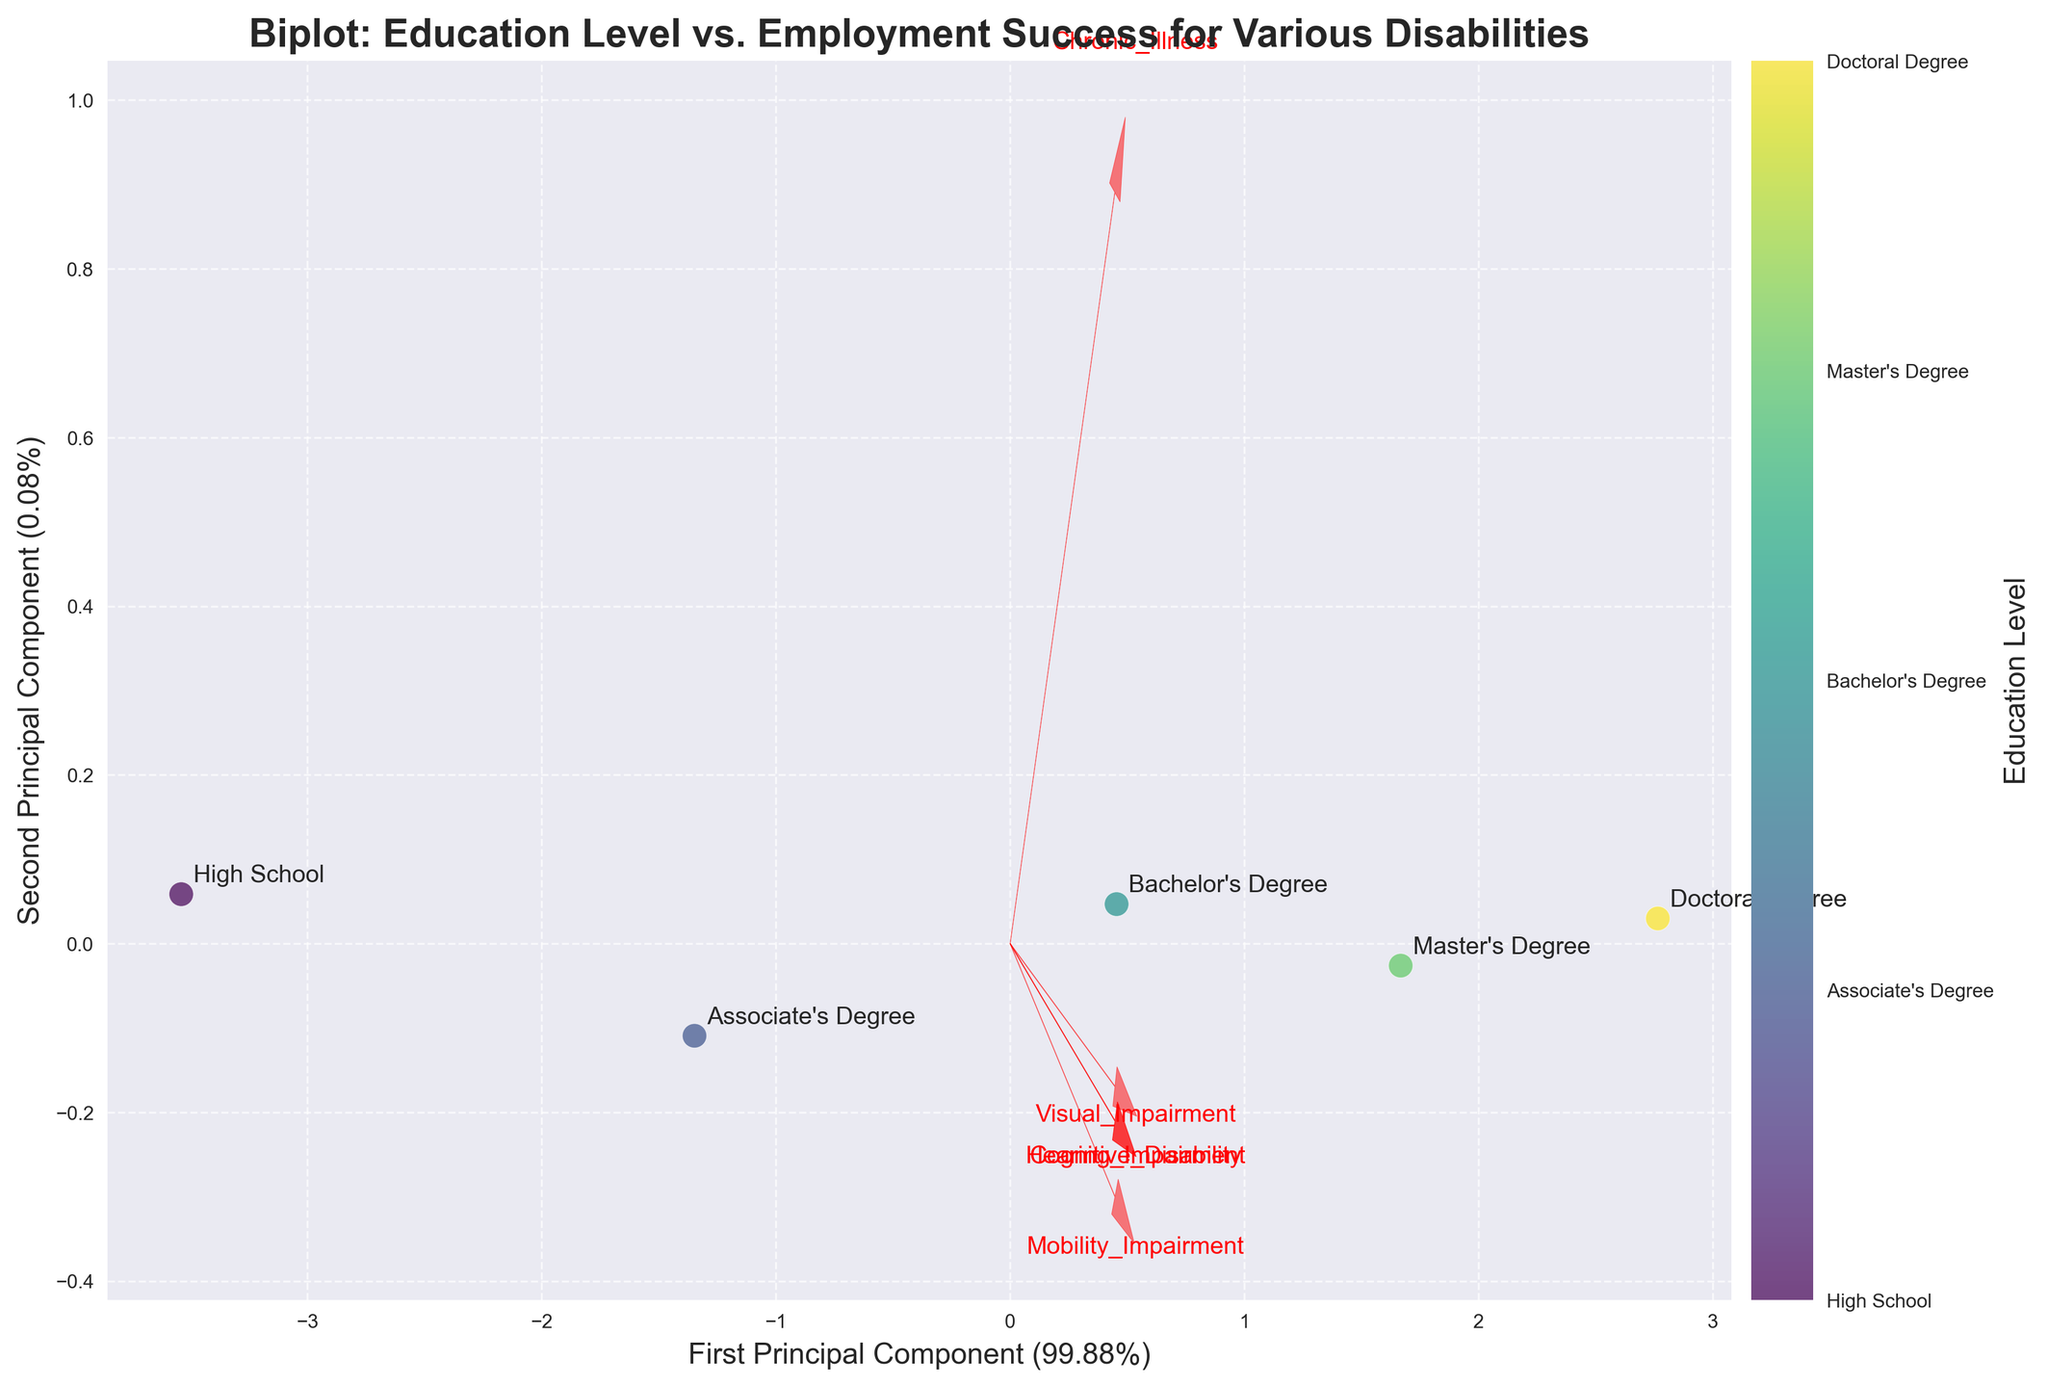How many data points are plotted in the figure? The scatter plot displays labeled points for each level of education. By counting the labels, we see there are data points for High School, Associate's Degree, Bachelor's Degree, Master's Degree, and Doctoral Degree.
Answer: Five What are the axes labeled in the biplot? The horizontal axis is labeled 'First Principal Component (percentage)', and the vertical axis is labeled 'Second Principal Component (percentage)'. The exact percentages represent the explained variance by each principal component.
Answer: First Principal Component and Second Principal Component Which education level appears closest to the 'Visual Impairment' vector in the plot? By observing the positions of the labeled points relative to the feature vectors, 'Doctoral Degree' seems closest to the 'Visual Impairment' vector in the biplot.
Answer: Doctoral Degree What trend do you observe between employment success and education level based on the plot? As the education level increases from High School to Doctoral Degree, the scatter points move farther right along the first principal component axis, indicating a correlation between higher education levels and higher employment success.
Answer: Higher education correlates with higher employment success Which disability feature vector is aligned closest to the first principal component? By observing the vectors overlaid on the principal components, the 'Hearing Impairment' vector appears most aligned with the first principal component.
Answer: Hearing Impairment Between 'Bachelor's Degree' and 'Master's Degree', which has higher variation along the second principal component? The biplot shows the vertical distance (second principal component axis) of the ‘Bachelor's Degree’ point is higher compared to 'Master's Degree'. Thus, 'Bachelor's Degree' shows higher variation along the second principal component.
Answer: Bachelor's Degree Do 'Cognitive Disability' and 'Chronic Illness' vectors point in similar directions in the plot? By visually inspecting the plot, both the 'Cognitive Disability' and 'Chronic Illness' vectors point in directions that are not aligned closely. ‘Cognitive Disability’ is more aligned with the second principal component, whereas 'Chronic Illness' is positioned more centrally.
Answer: No Which education level shows the least employment success? Observing the scatter plot, the 'High School' point is positioned lowest on the first principal component axis, indicating that this education level corresponds to the least employment success.
Answer: High School How does the employment success correlate with 'Mobility Impairment' based on the biplot? In the plot, the 'Mobility Impairment' vector is positively directed along both principal components, suggesting that employment success factors in education levels are positively correlated with 'Mobility Impairment'.
Answer: Positive correlation What can be inferred about the relationship between 'Doctoral Degree' and 'Cognitive Disability'? The 'Doctoral Degree' point is positioned further away from the 'Cognitive Disability' vector compared to other disabilities, suggesting a weaker or less direct correlation.
Answer: Weaker correlation 